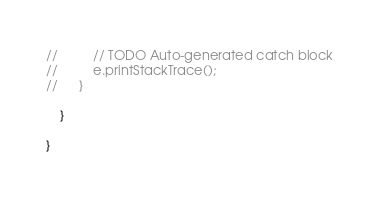Convert code to text. <code><loc_0><loc_0><loc_500><loc_500><_Java_>//			// TODO Auto-generated catch block
//			e.printStackTrace();
//		}

	}

}
</code> 